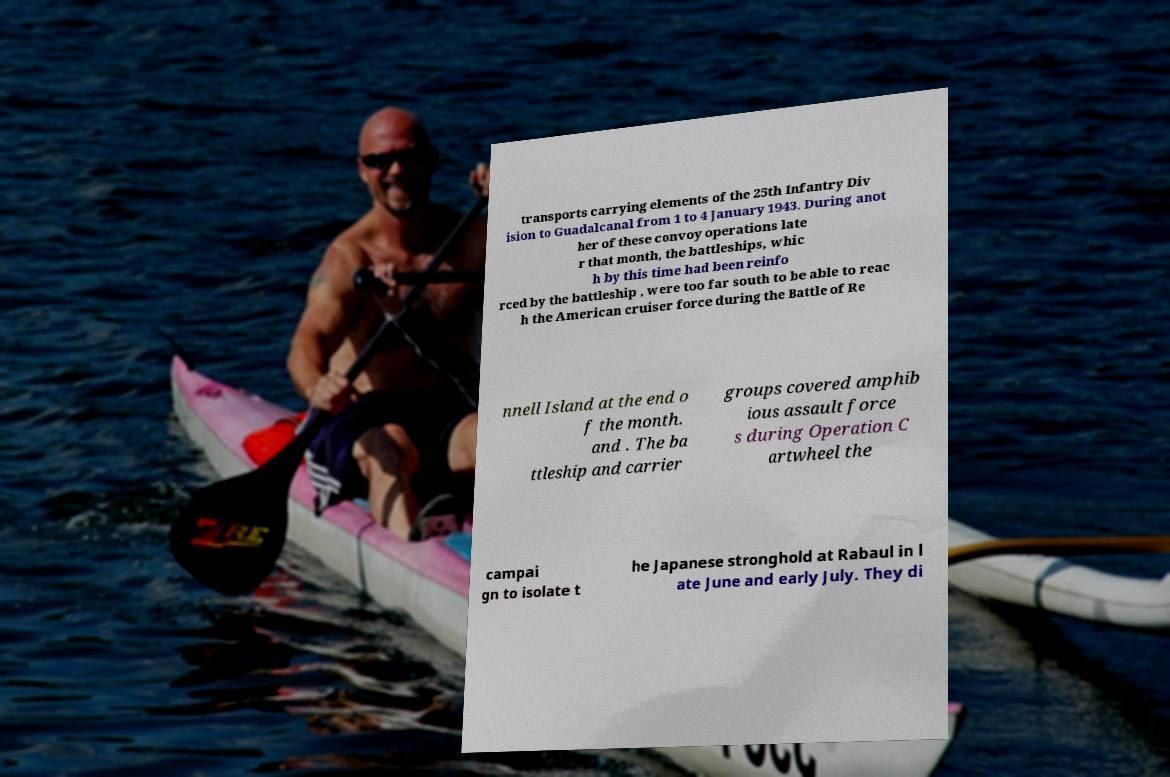There's text embedded in this image that I need extracted. Can you transcribe it verbatim? transports carrying elements of the 25th Infantry Div ision to Guadalcanal from 1 to 4 January 1943. During anot her of these convoy operations late r that month, the battleships, whic h by this time had been reinfo rced by the battleship , were too far south to be able to reac h the American cruiser force during the Battle of Re nnell Island at the end o f the month. and . The ba ttleship and carrier groups covered amphib ious assault force s during Operation C artwheel the campai gn to isolate t he Japanese stronghold at Rabaul in l ate June and early July. They di 